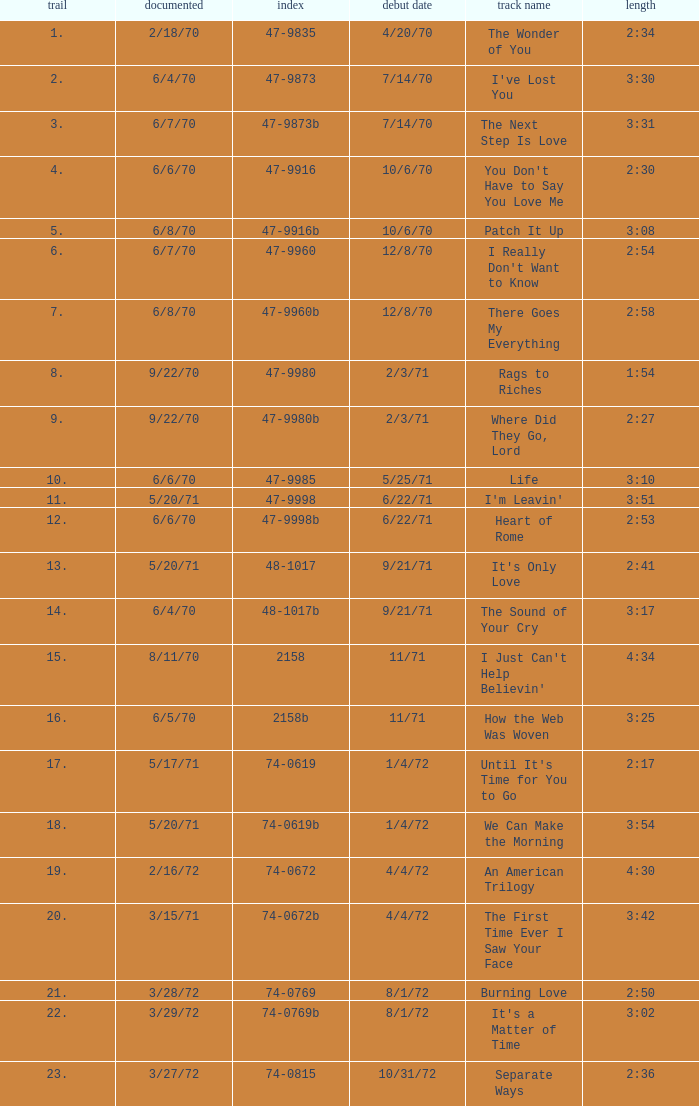Which song was released 12/8/70 with a time of 2:54? I Really Don't Want to Know. Could you parse the entire table as a dict? {'header': ['trail', 'documented', 'index', 'debut date', 'track name', 'length'], 'rows': [['1.', '2/18/70', '47-9835', '4/20/70', 'The Wonder of You', '2:34'], ['2.', '6/4/70', '47-9873', '7/14/70', "I've Lost You", '3:30'], ['3.', '6/7/70', '47-9873b', '7/14/70', 'The Next Step Is Love', '3:31'], ['4.', '6/6/70', '47-9916', '10/6/70', "You Don't Have to Say You Love Me", '2:30'], ['5.', '6/8/70', '47-9916b', '10/6/70', 'Patch It Up', '3:08'], ['6.', '6/7/70', '47-9960', '12/8/70', "I Really Don't Want to Know", '2:54'], ['7.', '6/8/70', '47-9960b', '12/8/70', 'There Goes My Everything', '2:58'], ['8.', '9/22/70', '47-9980', '2/3/71', 'Rags to Riches', '1:54'], ['9.', '9/22/70', '47-9980b', '2/3/71', 'Where Did They Go, Lord', '2:27'], ['10.', '6/6/70', '47-9985', '5/25/71', 'Life', '3:10'], ['11.', '5/20/71', '47-9998', '6/22/71', "I'm Leavin'", '3:51'], ['12.', '6/6/70', '47-9998b', '6/22/71', 'Heart of Rome', '2:53'], ['13.', '5/20/71', '48-1017', '9/21/71', "It's Only Love", '2:41'], ['14.', '6/4/70', '48-1017b', '9/21/71', 'The Sound of Your Cry', '3:17'], ['15.', '8/11/70', '2158', '11/71', "I Just Can't Help Believin'", '4:34'], ['16.', '6/5/70', '2158b', '11/71', 'How the Web Was Woven', '3:25'], ['17.', '5/17/71', '74-0619', '1/4/72', "Until It's Time for You to Go", '2:17'], ['18.', '5/20/71', '74-0619b', '1/4/72', 'We Can Make the Morning', '3:54'], ['19.', '2/16/72', '74-0672', '4/4/72', 'An American Trilogy', '4:30'], ['20.', '3/15/71', '74-0672b', '4/4/72', 'The First Time Ever I Saw Your Face', '3:42'], ['21.', '3/28/72', '74-0769', '8/1/72', 'Burning Love', '2:50'], ['22.', '3/29/72', '74-0769b', '8/1/72', "It's a Matter of Time", '3:02'], ['23.', '3/27/72', '74-0815', '10/31/72', 'Separate Ways', '2:36']]} 